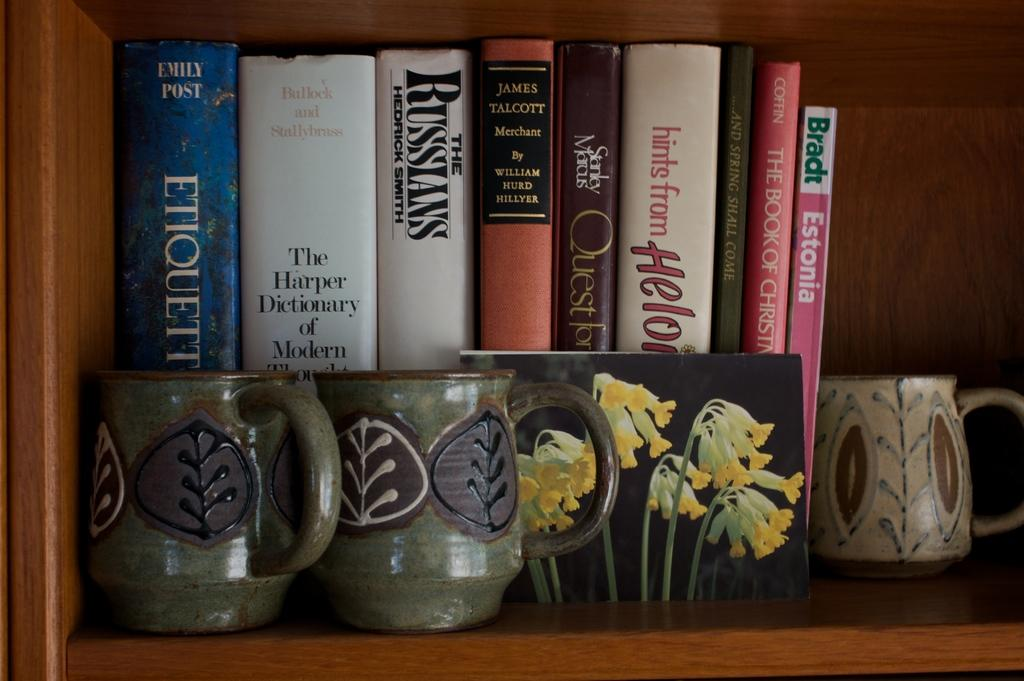<image>
Write a terse but informative summary of the picture. A blue book by Emily Post called Etiquette sits on a shelf in front of two green mugs 